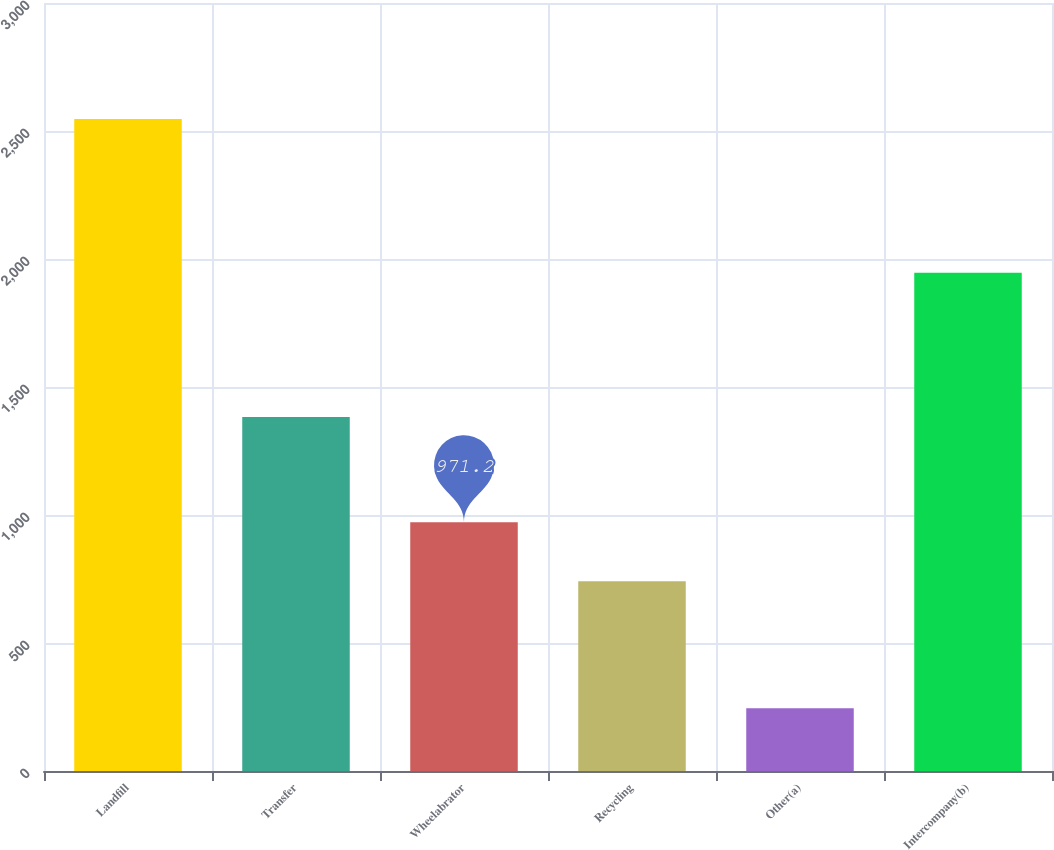Convert chart to OTSL. <chart><loc_0><loc_0><loc_500><loc_500><bar_chart><fcel>Landfill<fcel>Transfer<fcel>Wheelabrator<fcel>Recycling<fcel>Other(a)<fcel>Intercompany(b)<nl><fcel>2547<fcel>1383<fcel>971.2<fcel>741<fcel>245<fcel>1946<nl></chart> 